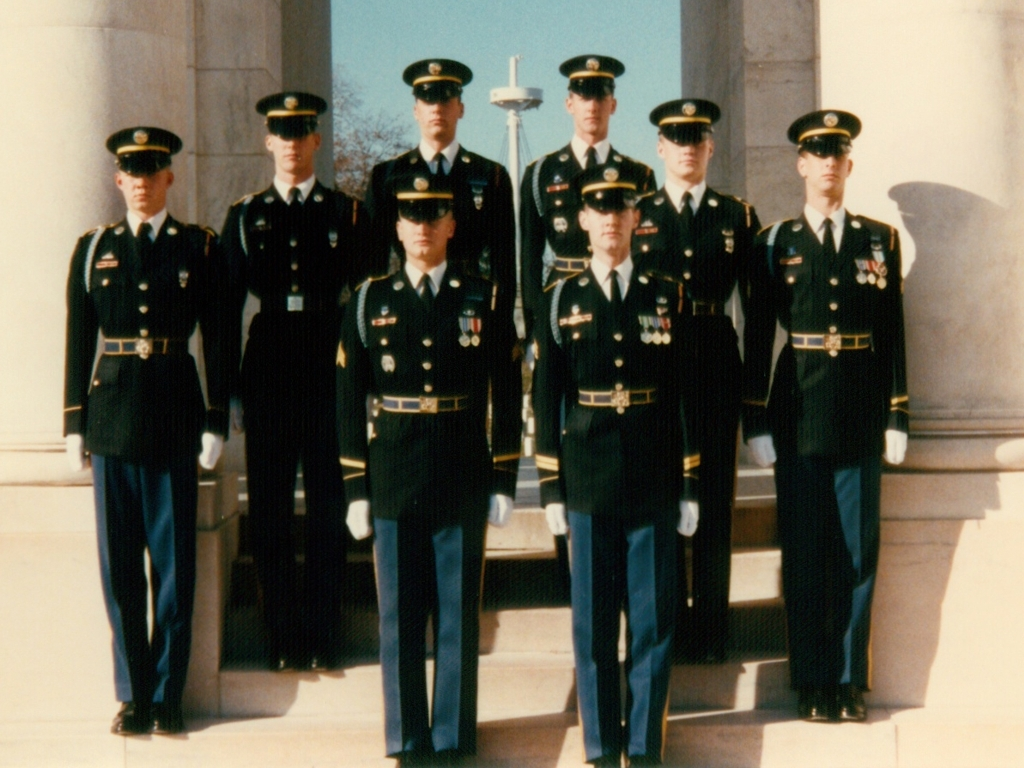How would you describe the image quality?
A. Good
B. Poor
C. Average
Answer with the option's letter from the given choices directly. The image quality is best described as average, or option C. While the subjects are distinguishable and the colors appear true, there's visible graininess and some lack of sharpness which hinders the image from being classified as having high quality. 